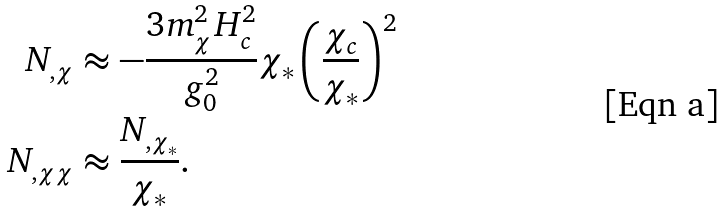Convert formula to latex. <formula><loc_0><loc_0><loc_500><loc_500>N _ { , \chi } & \approx - \frac { 3 m _ { \chi } ^ { 2 } H _ { c } ^ { 2 } } { g _ { 0 } ^ { 2 } } \chi _ { * } \left ( \frac { \chi _ { c } } { \chi _ { * } } \right ) ^ { 2 } \\ N _ { , \chi \chi } & \approx \frac { N _ { , \chi _ { * } } } { \chi _ { * } } .</formula> 